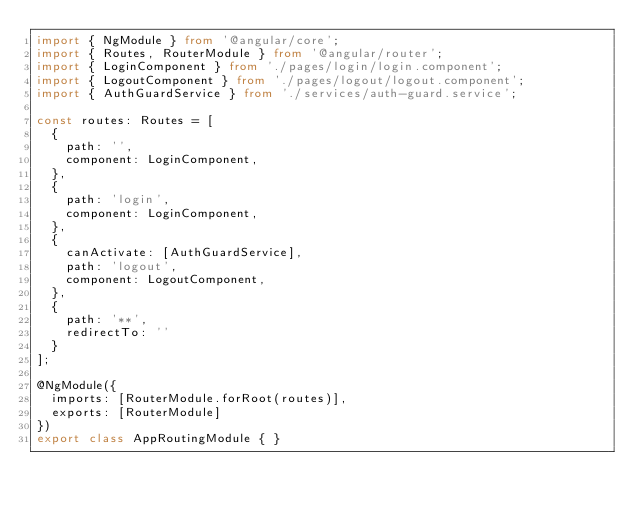Convert code to text. <code><loc_0><loc_0><loc_500><loc_500><_TypeScript_>import { NgModule } from '@angular/core';
import { Routes, RouterModule } from '@angular/router';
import { LoginComponent } from './pages/login/login.component';
import { LogoutComponent } from './pages/logout/logout.component';
import { AuthGuardService } from './services/auth-guard.service';

const routes: Routes = [
  {
    path: '',
    component: LoginComponent,
  },
  {
    path: 'login',
    component: LoginComponent,
  },
  {
    canActivate: [AuthGuardService],
    path: 'logout',
    component: LogoutComponent,
  },
  {
    path: '**',
    redirectTo: ''
  }
];

@NgModule({
  imports: [RouterModule.forRoot(routes)],
  exports: [RouterModule]
})
export class AppRoutingModule { }
</code> 